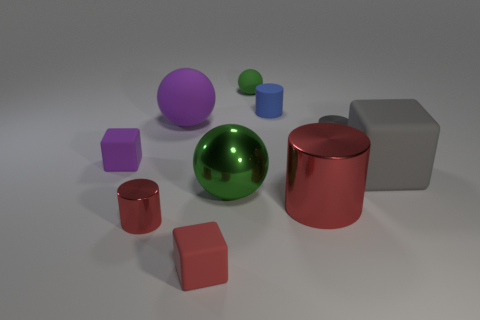Is there any other thing that is the same size as the gray block?
Provide a succinct answer. Yes. Is the color of the sphere on the right side of the big metallic sphere the same as the small matte object to the left of the big purple object?
Ensure brevity in your answer.  No. Is the number of large balls right of the small red matte cube greater than the number of large red objects in front of the large red metallic cylinder?
Ensure brevity in your answer.  Yes. What color is the large thing that is the same shape as the small blue thing?
Provide a short and direct response. Red. Are there any other things that are the same shape as the big green thing?
Your answer should be compact. Yes. There is a tiny green rubber thing; is it the same shape as the large matte object that is to the left of the tiny green matte thing?
Provide a succinct answer. Yes. What number of other objects are there of the same material as the gray block?
Make the answer very short. 5. Does the metal ball have the same color as the matte ball that is to the right of the small red matte thing?
Your answer should be very brief. Yes. There is a tiny cube that is behind the gray matte cube; what material is it?
Ensure brevity in your answer.  Rubber. Are there any tiny metallic cylinders of the same color as the metal ball?
Provide a succinct answer. No. 